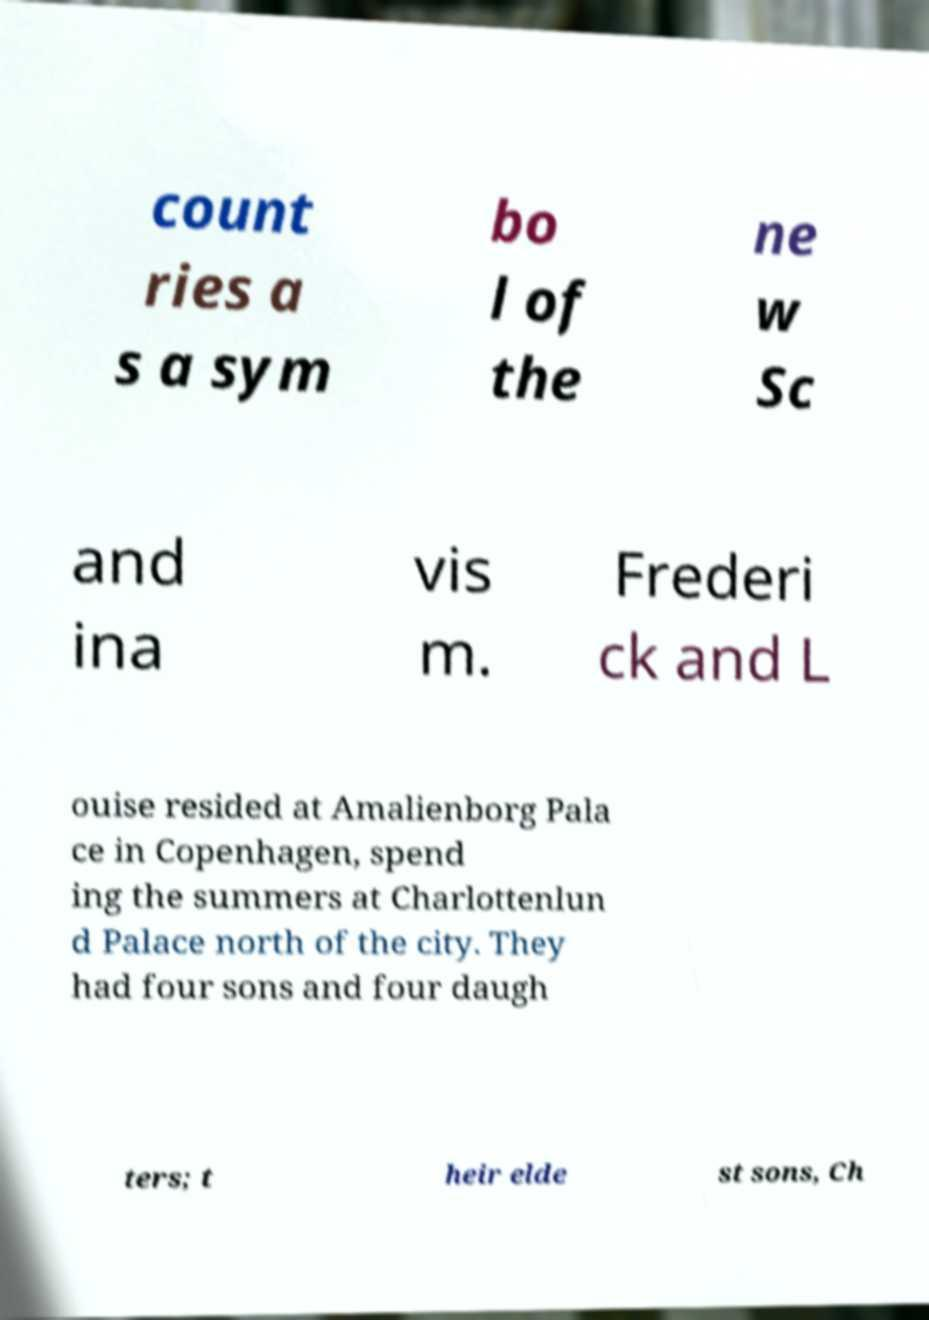What messages or text are displayed in this image? I need them in a readable, typed format. count ries a s a sym bo l of the ne w Sc and ina vis m. Frederi ck and L ouise resided at Amalienborg Pala ce in Copenhagen, spend ing the summers at Charlottenlun d Palace north of the city. They had four sons and four daugh ters; t heir elde st sons, Ch 